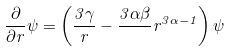Convert formula to latex. <formula><loc_0><loc_0><loc_500><loc_500>\frac { \partial } { \partial r } \psi = \left ( \frac { 3 \gamma } { r } - \frac { 3 \alpha \beta } { } r ^ { 3 \alpha - 1 } \right ) \psi</formula> 